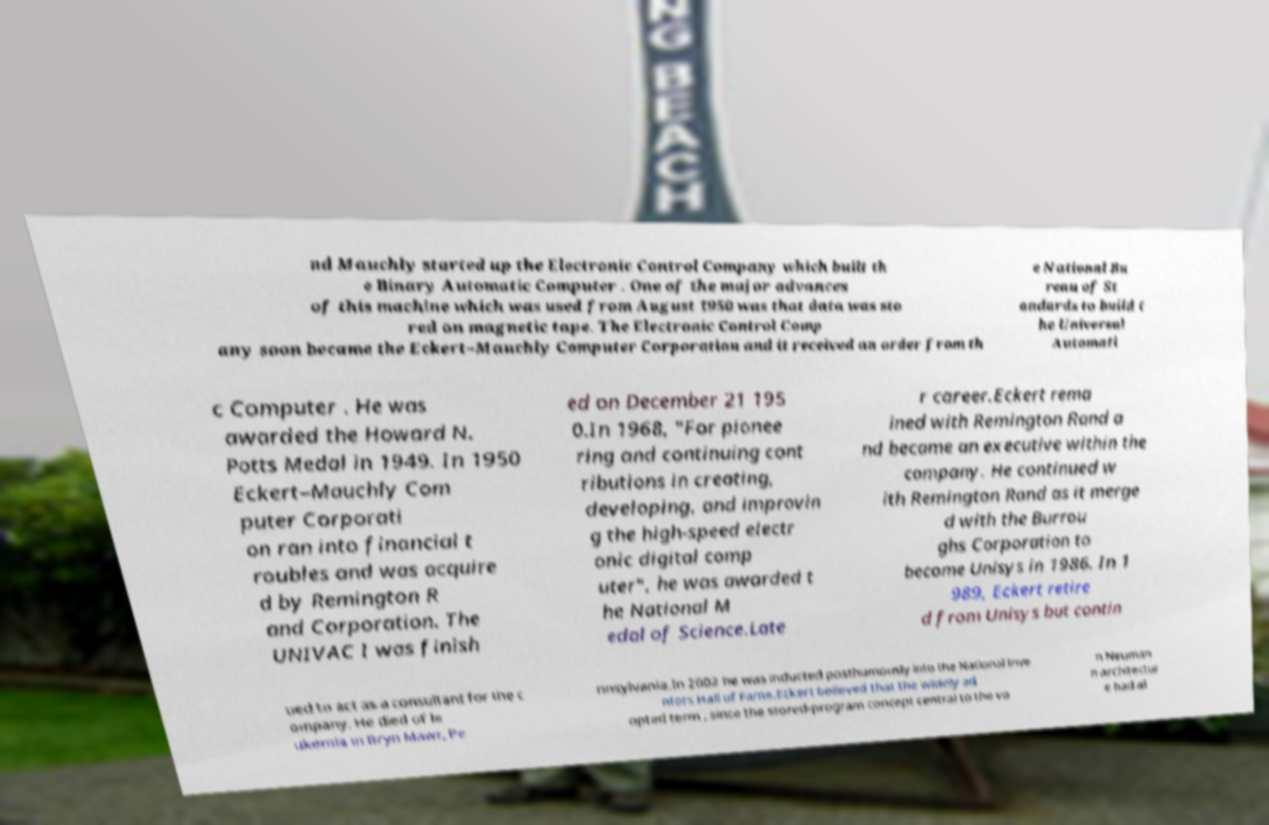Can you read and provide the text displayed in the image?This photo seems to have some interesting text. Can you extract and type it out for me? nd Mauchly started up the Electronic Control Company which built th e Binary Automatic Computer . One of the major advances of this machine which was used from August 1950 was that data was sto red on magnetic tape. The Electronic Control Comp any soon became the Eckert–Mauchly Computer Corporation and it received an order from th e National Bu reau of St andards to build t he Universal Automati c Computer . He was awarded the Howard N. Potts Medal in 1949. In 1950 Eckert–Mauchly Com puter Corporati on ran into financial t roubles and was acquire d by Remington R and Corporation. The UNIVAC I was finish ed on December 21 195 0.In 1968, "For pionee ring and continuing cont ributions in creating, developing, and improvin g the high-speed electr onic digital comp uter", he was awarded t he National M edal of Science.Late r career.Eckert rema ined with Remington Rand a nd became an executive within the company. He continued w ith Remington Rand as it merge d with the Burrou ghs Corporation to become Unisys in 1986. In 1 989, Eckert retire d from Unisys but contin ued to act as a consultant for the c ompany. He died of le ukemia in Bryn Mawr, Pe nnsylvania.In 2002 he was inducted posthumously into the National Inve ntors Hall of Fame.Eckert believed that the widely ad opted term , since the stored-program concept central to the vo n Neuman n architectur e had al 